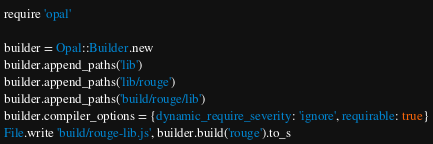Convert code to text. <code><loc_0><loc_0><loc_500><loc_500><_Ruby_>require 'opal'

builder = Opal::Builder.new
builder.append_paths('lib')
builder.append_paths('lib/rouge')
builder.append_paths('build/rouge/lib')
builder.compiler_options = {dynamic_require_severity: 'ignore', requirable: true}
File.write 'build/rouge-lib.js', builder.build('rouge').to_s
</code> 